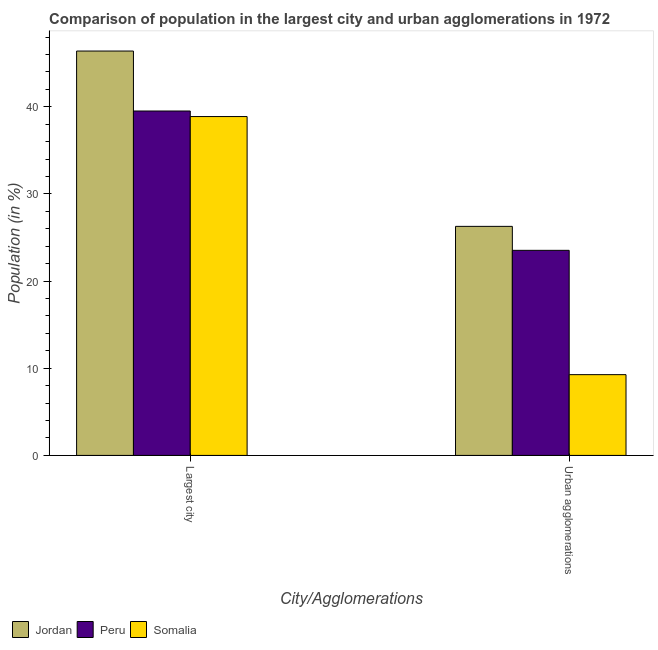How many groups of bars are there?
Make the answer very short. 2. Are the number of bars on each tick of the X-axis equal?
Your answer should be compact. Yes. How many bars are there on the 1st tick from the right?
Keep it short and to the point. 3. What is the label of the 1st group of bars from the left?
Ensure brevity in your answer.  Largest city. What is the population in the largest city in Jordan?
Offer a terse response. 46.4. Across all countries, what is the maximum population in the largest city?
Your answer should be very brief. 46.4. Across all countries, what is the minimum population in the largest city?
Keep it short and to the point. 38.88. In which country was the population in the largest city maximum?
Offer a terse response. Jordan. In which country was the population in urban agglomerations minimum?
Provide a short and direct response. Somalia. What is the total population in urban agglomerations in the graph?
Give a very brief answer. 59.08. What is the difference between the population in urban agglomerations in Somalia and that in Peru?
Provide a succinct answer. -14.26. What is the difference between the population in the largest city in Somalia and the population in urban agglomerations in Jordan?
Your answer should be compact. 12.6. What is the average population in the largest city per country?
Ensure brevity in your answer.  41.6. What is the difference between the population in urban agglomerations and population in the largest city in Somalia?
Offer a very short reply. -29.61. In how many countries, is the population in urban agglomerations greater than 2 %?
Your response must be concise. 3. What is the ratio of the population in the largest city in Somalia to that in Peru?
Your response must be concise. 0.98. Is the population in the largest city in Jordan less than that in Peru?
Your answer should be compact. No. What does the 1st bar from the left in Largest city represents?
Offer a very short reply. Jordan. What does the 2nd bar from the right in Largest city represents?
Your response must be concise. Peru. Are all the bars in the graph horizontal?
Your response must be concise. No. How many countries are there in the graph?
Offer a terse response. 3. What is the difference between two consecutive major ticks on the Y-axis?
Keep it short and to the point. 10. Are the values on the major ticks of Y-axis written in scientific E-notation?
Keep it short and to the point. No. Does the graph contain any zero values?
Provide a succinct answer. No. Where does the legend appear in the graph?
Provide a short and direct response. Bottom left. What is the title of the graph?
Your response must be concise. Comparison of population in the largest city and urban agglomerations in 1972. What is the label or title of the X-axis?
Ensure brevity in your answer.  City/Agglomerations. What is the Population (in %) in Jordan in Largest city?
Give a very brief answer. 46.4. What is the Population (in %) in Peru in Largest city?
Provide a succinct answer. 39.52. What is the Population (in %) in Somalia in Largest city?
Keep it short and to the point. 38.88. What is the Population (in %) in Jordan in Urban agglomerations?
Provide a short and direct response. 26.28. What is the Population (in %) in Peru in Urban agglomerations?
Keep it short and to the point. 23.53. What is the Population (in %) of Somalia in Urban agglomerations?
Your answer should be very brief. 9.27. Across all City/Agglomerations, what is the maximum Population (in %) of Jordan?
Your answer should be compact. 46.4. Across all City/Agglomerations, what is the maximum Population (in %) in Peru?
Provide a succinct answer. 39.52. Across all City/Agglomerations, what is the maximum Population (in %) in Somalia?
Offer a terse response. 38.88. Across all City/Agglomerations, what is the minimum Population (in %) in Jordan?
Keep it short and to the point. 26.28. Across all City/Agglomerations, what is the minimum Population (in %) in Peru?
Ensure brevity in your answer.  23.53. Across all City/Agglomerations, what is the minimum Population (in %) of Somalia?
Ensure brevity in your answer.  9.27. What is the total Population (in %) of Jordan in the graph?
Give a very brief answer. 72.68. What is the total Population (in %) in Peru in the graph?
Provide a short and direct response. 63.05. What is the total Population (in %) of Somalia in the graph?
Make the answer very short. 48.15. What is the difference between the Population (in %) of Jordan in Largest city and that in Urban agglomerations?
Provide a succinct answer. 20.12. What is the difference between the Population (in %) in Peru in Largest city and that in Urban agglomerations?
Your answer should be very brief. 15.99. What is the difference between the Population (in %) in Somalia in Largest city and that in Urban agglomerations?
Provide a short and direct response. 29.61. What is the difference between the Population (in %) in Jordan in Largest city and the Population (in %) in Peru in Urban agglomerations?
Make the answer very short. 22.87. What is the difference between the Population (in %) in Jordan in Largest city and the Population (in %) in Somalia in Urban agglomerations?
Offer a terse response. 37.13. What is the difference between the Population (in %) in Peru in Largest city and the Population (in %) in Somalia in Urban agglomerations?
Offer a very short reply. 30.25. What is the average Population (in %) of Jordan per City/Agglomerations?
Offer a terse response. 36.34. What is the average Population (in %) of Peru per City/Agglomerations?
Your answer should be compact. 31.52. What is the average Population (in %) of Somalia per City/Agglomerations?
Your answer should be compact. 24.07. What is the difference between the Population (in %) of Jordan and Population (in %) of Peru in Largest city?
Keep it short and to the point. 6.88. What is the difference between the Population (in %) of Jordan and Population (in %) of Somalia in Largest city?
Keep it short and to the point. 7.52. What is the difference between the Population (in %) in Peru and Population (in %) in Somalia in Largest city?
Keep it short and to the point. 0.64. What is the difference between the Population (in %) in Jordan and Population (in %) in Peru in Urban agglomerations?
Keep it short and to the point. 2.75. What is the difference between the Population (in %) in Jordan and Population (in %) in Somalia in Urban agglomerations?
Your answer should be very brief. 17.02. What is the difference between the Population (in %) in Peru and Population (in %) in Somalia in Urban agglomerations?
Your answer should be compact. 14.26. What is the ratio of the Population (in %) of Jordan in Largest city to that in Urban agglomerations?
Offer a terse response. 1.77. What is the ratio of the Population (in %) of Peru in Largest city to that in Urban agglomerations?
Give a very brief answer. 1.68. What is the ratio of the Population (in %) in Somalia in Largest city to that in Urban agglomerations?
Make the answer very short. 4.2. What is the difference between the highest and the second highest Population (in %) in Jordan?
Provide a short and direct response. 20.12. What is the difference between the highest and the second highest Population (in %) of Peru?
Provide a short and direct response. 15.99. What is the difference between the highest and the second highest Population (in %) in Somalia?
Provide a succinct answer. 29.61. What is the difference between the highest and the lowest Population (in %) of Jordan?
Make the answer very short. 20.12. What is the difference between the highest and the lowest Population (in %) in Peru?
Offer a very short reply. 15.99. What is the difference between the highest and the lowest Population (in %) of Somalia?
Ensure brevity in your answer.  29.61. 